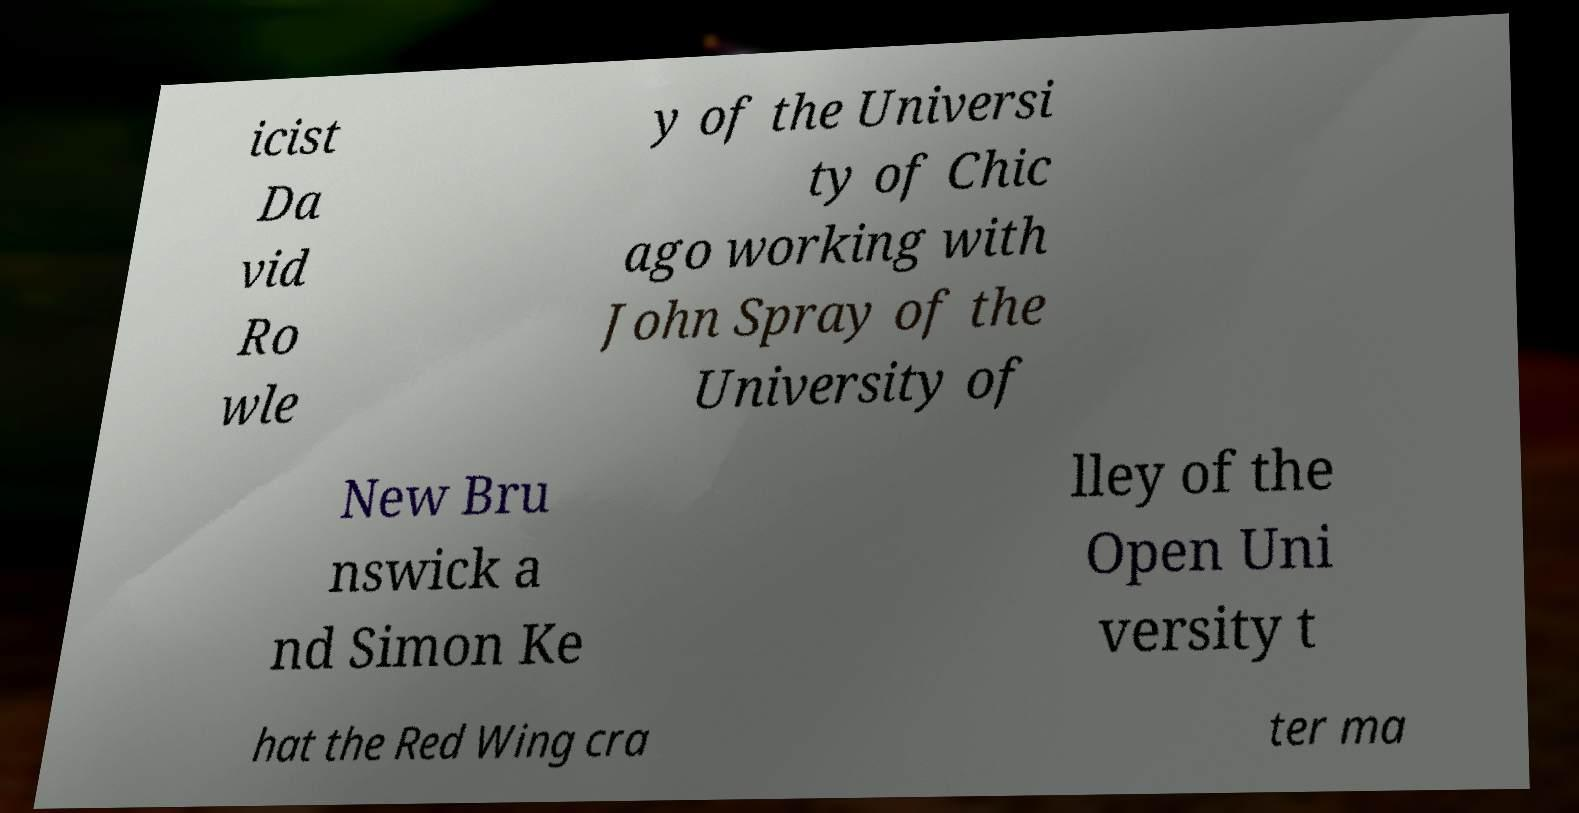Can you read and provide the text displayed in the image?This photo seems to have some interesting text. Can you extract and type it out for me? icist Da vid Ro wle y of the Universi ty of Chic ago working with John Spray of the University of New Bru nswick a nd Simon Ke lley of the Open Uni versity t hat the Red Wing cra ter ma 